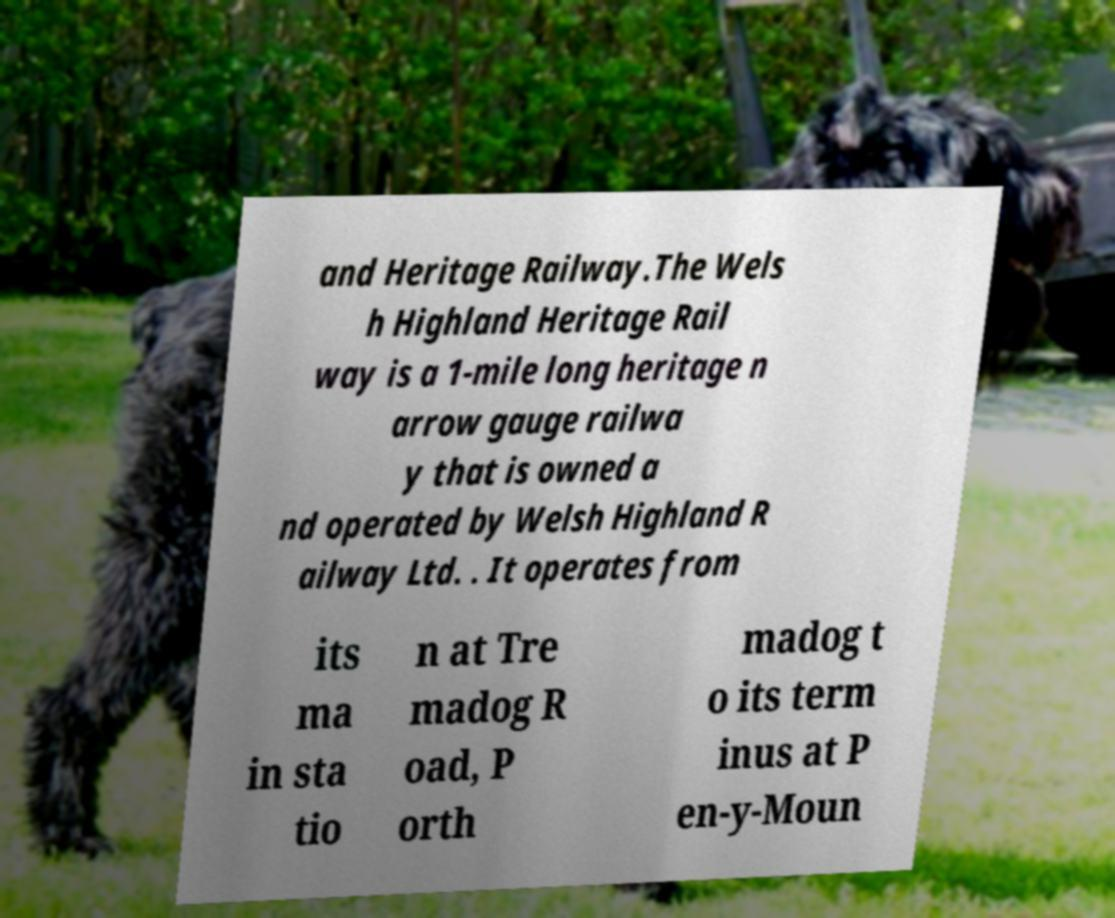Could you extract and type out the text from this image? and Heritage Railway.The Wels h Highland Heritage Rail way is a 1-mile long heritage n arrow gauge railwa y that is owned a nd operated by Welsh Highland R ailway Ltd. . It operates from its ma in sta tio n at Tre madog R oad, P orth madog t o its term inus at P en-y-Moun 